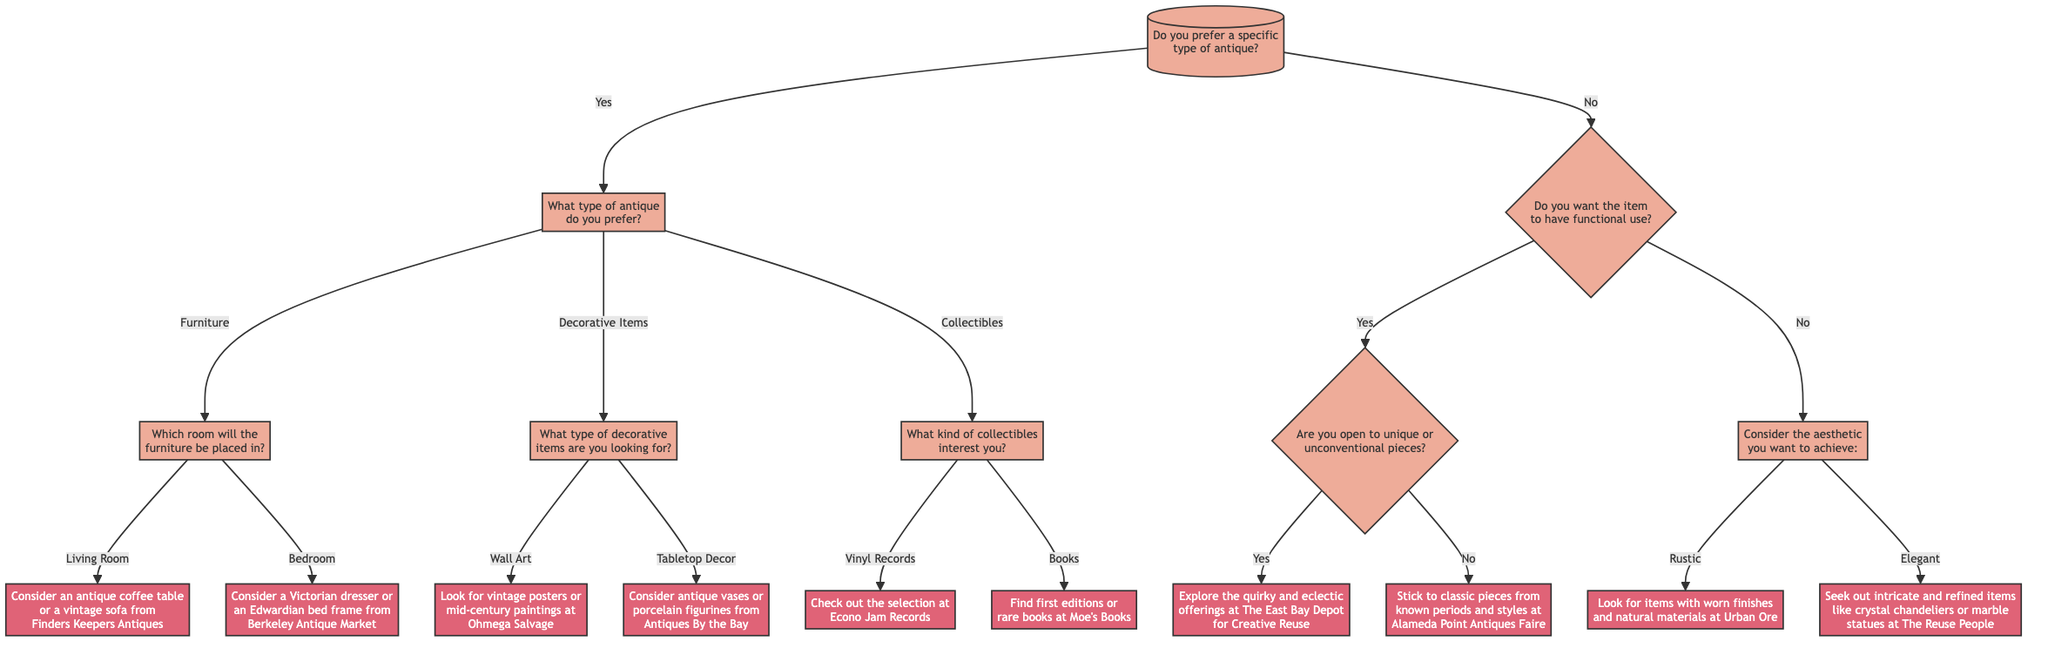What is the first question in the decision tree? The first question in the decision tree is located at node 1, which asks if the user prefers a specific type of antique.
Answer: Do you prefer a specific type of antique? What are the options provided under the second question? The second question, found in node 2, offers three choices: Furniture, Decorative Items, and Collectibles, providing distinct paths in the decision tree.
Answer: Furniture, Decorative Items, Collectibles How many nodes are present in this decision tree? By counting all unique decision points and actions presented in the diagram, we can identify that there are a total of 10 nodes within the decision tree structure.
Answer: 10 What happens if you answer "Yes" to the question about functional use? If the answer is "Yes," the flow moves to node 7, where the next query asks if the user is open to unique or unconventional pieces, affecting the subsequent decision.
Answer: Are you open to unique or unconventional pieces? If you choose "Books" as a collectible, what is the recommendation? Choosing "Books" at node 6 leads you to node 6B, which recommends finding first editions or rare books at Moe's Books, a specific location for sourcing this type of collectible.
Answer: Find first editions or rare books at Moe's Books What does node 8 ask about? Node 8 focuses on the aesthetic that the user wants to achieve by presenting two options, Rustic and Elegant, guiding the decision based on visual preferences and style.
Answer: Consider the aesthetic you want to achieve: If you prefer Rustic items, where do you go shopping? If you indicate you prefer a Rustic aesthetic in node 8, the recommendation in node 8A suggests looking for items with worn finishes and natural materials at Urban Ore.
Answer: Look for items with worn finishes and natural materials at Urban Ore What is the final action if you say "No" to being open to unique pieces? Responding "No" to the inquiry at node 7 leads to an action at node 10, recommending to stick to classic pieces from known periods and styles at Alameda Point Antiques Faire.
Answer: Stick to classic pieces from known periods and styles at Alameda Point Antiques Faire What does the second action node recommend when selecting Decorative Items? The node associated with Decorative Items offers two specific paths, where selecting Wall Art leads to recommendations for vintage posters or mid-century paintings at Ohmega Salvage.
Answer: Look for vintage posters or mid-century paintings at Ohmega Salvage What type of antique would you consider for a bedroom? For the Bedroom option under node 4, it suggests considering a Victorian dresser or an Edwardian bed frame from Berkeley Antique Market as ideal choices for this space.
Answer: Consider a Victorian dresser or an Edwardian bed frame from Berkeley Antique Market 